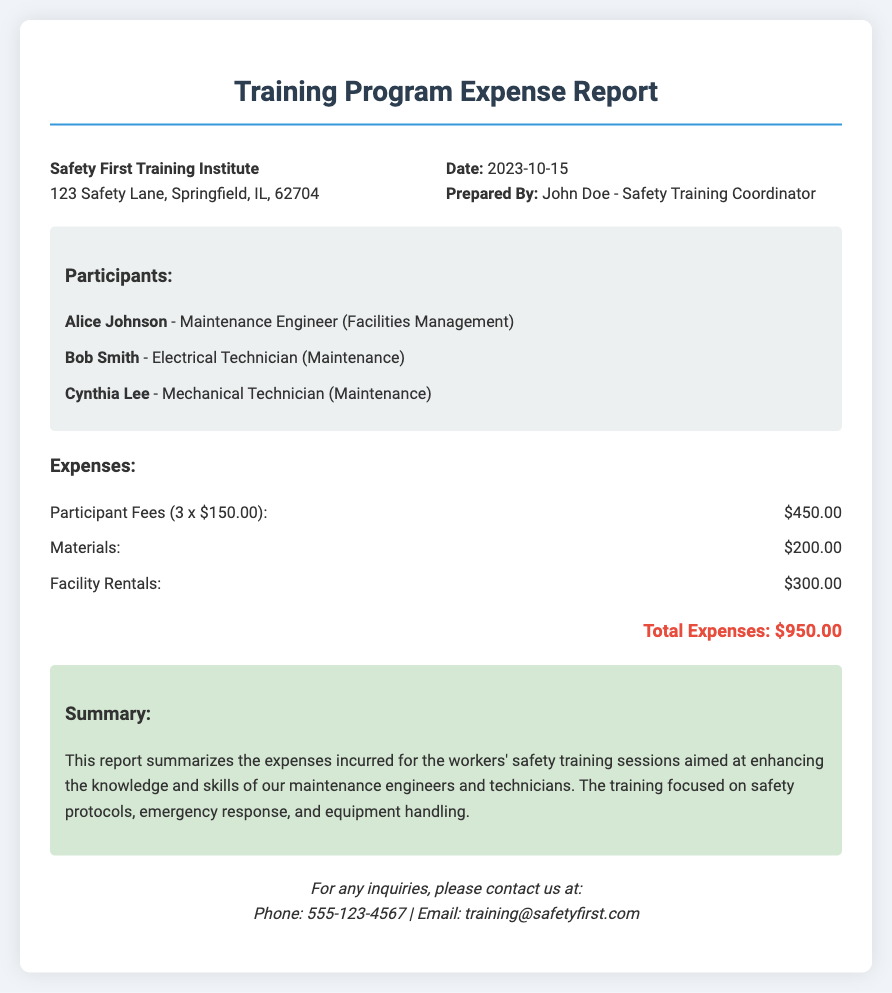What is the date of the report? The date of the report is clearly indicated at the top, listed under the report info section.
Answer: 2023-10-15 Who prepared the report? The name of the person who prepared the report is mentioned in the report info section.
Answer: John Doe - Safety Training Coordinator How many participants were there? The number of participants can be identified by counting the individual entries listed under the participants section.
Answer: 3 What is the total amount for participant fees? The total participant fees are calculated by multiplying the number of participants by the fee per participant, as shown in the expenses section.
Answer: $450.00 What type of training was summarized in the report? The summary outlines the focus areas of the training program, which can be found in the summary section.
Answer: Safety protocols, emergency response, and equipment handling What is the expense for materials? The expense for materials is listed specifically in the expenses section of the report.
Answer: $200.00 What organization is this report from? The organization responsible for the report is prominently displayed at the beginning of the document.
Answer: Safety First Training Institute What is the total of all expenses reported? The total expenses can be found at the bottom of the expenses section, providing a clear total after itemization.
Answer: $950.00 What is the contact phone number for inquiries? The contact information including the phone number can be found in the contact section at the end of the document.
Answer: 555-123-4567 